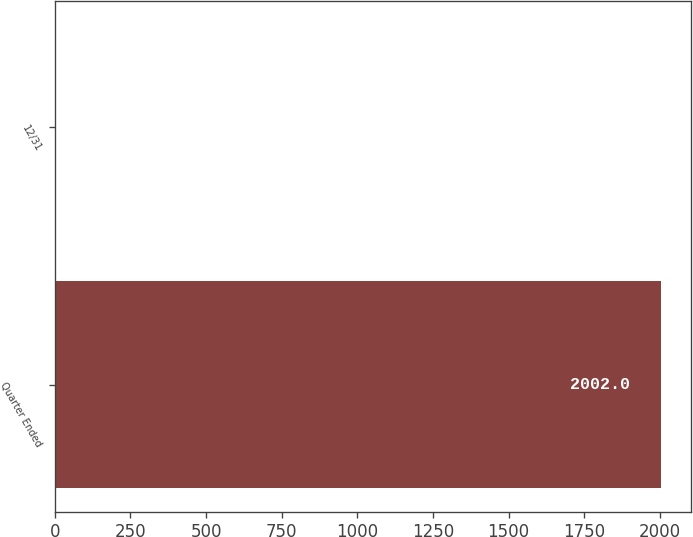Convert chart. <chart><loc_0><loc_0><loc_500><loc_500><bar_chart><fcel>Quarter Ended<fcel>12/31<nl><fcel>2002<fcel>0.77<nl></chart> 